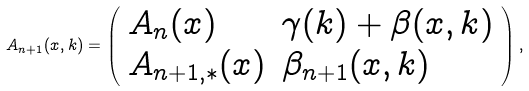<formula> <loc_0><loc_0><loc_500><loc_500>A _ { n + 1 } ( x , k ) = \left ( \begin{array} { l l } A _ { n } ( x ) & \gamma ( k ) + \beta ( x , k ) \\ A _ { n + 1 , * } ( x ) & \beta _ { n + 1 } ( x , k ) \end{array} \right ) ,</formula> 